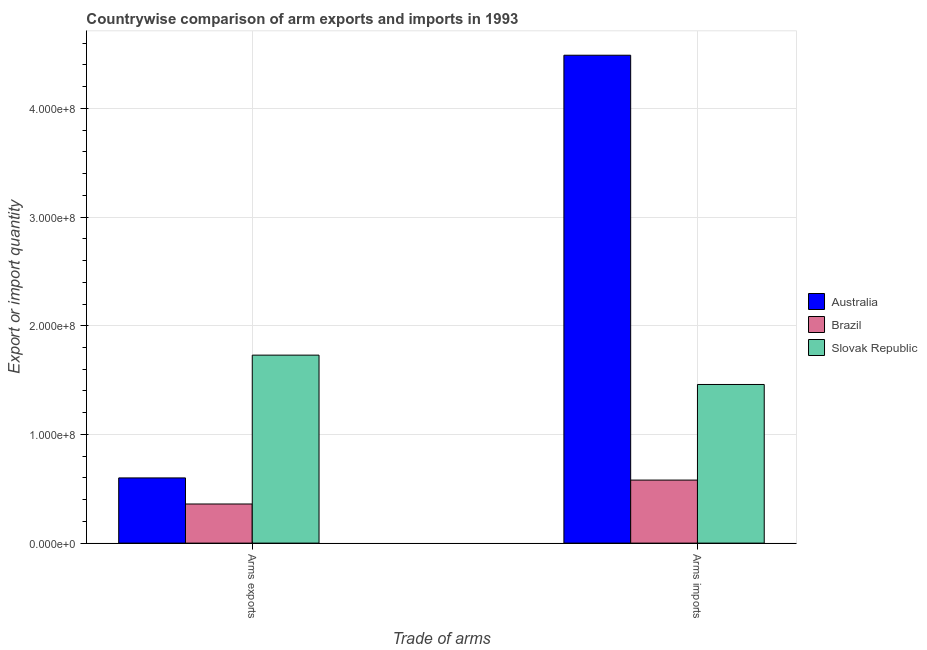How many groups of bars are there?
Keep it short and to the point. 2. Are the number of bars on each tick of the X-axis equal?
Your response must be concise. Yes. How many bars are there on the 1st tick from the left?
Offer a terse response. 3. What is the label of the 2nd group of bars from the left?
Your answer should be very brief. Arms imports. What is the arms imports in Slovak Republic?
Your answer should be compact. 1.46e+08. Across all countries, what is the maximum arms imports?
Provide a succinct answer. 4.49e+08. Across all countries, what is the minimum arms imports?
Your answer should be compact. 5.80e+07. In which country was the arms exports minimum?
Ensure brevity in your answer.  Brazil. What is the total arms exports in the graph?
Your answer should be very brief. 2.69e+08. What is the difference between the arms exports in Australia and that in Brazil?
Your answer should be compact. 2.40e+07. What is the difference between the arms exports in Slovak Republic and the arms imports in Brazil?
Your answer should be compact. 1.15e+08. What is the average arms imports per country?
Provide a short and direct response. 2.18e+08. What is the difference between the arms exports and arms imports in Brazil?
Your answer should be compact. -2.20e+07. In how many countries, is the arms exports greater than 120000000 ?
Offer a very short reply. 1. What is the ratio of the arms exports in Slovak Republic to that in Brazil?
Your answer should be very brief. 4.81. What does the 3rd bar from the left in Arms exports represents?
Ensure brevity in your answer.  Slovak Republic. What does the 1st bar from the right in Arms exports represents?
Give a very brief answer. Slovak Republic. Are all the bars in the graph horizontal?
Provide a succinct answer. No. How many countries are there in the graph?
Give a very brief answer. 3. Are the values on the major ticks of Y-axis written in scientific E-notation?
Give a very brief answer. Yes. Does the graph contain grids?
Your answer should be compact. Yes. Where does the legend appear in the graph?
Make the answer very short. Center right. How many legend labels are there?
Your answer should be very brief. 3. What is the title of the graph?
Offer a terse response. Countrywise comparison of arm exports and imports in 1993. What is the label or title of the X-axis?
Keep it short and to the point. Trade of arms. What is the label or title of the Y-axis?
Your response must be concise. Export or import quantity. What is the Export or import quantity in Australia in Arms exports?
Make the answer very short. 6.00e+07. What is the Export or import quantity in Brazil in Arms exports?
Keep it short and to the point. 3.60e+07. What is the Export or import quantity of Slovak Republic in Arms exports?
Your response must be concise. 1.73e+08. What is the Export or import quantity of Australia in Arms imports?
Your response must be concise. 4.49e+08. What is the Export or import quantity in Brazil in Arms imports?
Your answer should be compact. 5.80e+07. What is the Export or import quantity of Slovak Republic in Arms imports?
Offer a terse response. 1.46e+08. Across all Trade of arms, what is the maximum Export or import quantity in Australia?
Offer a very short reply. 4.49e+08. Across all Trade of arms, what is the maximum Export or import quantity of Brazil?
Keep it short and to the point. 5.80e+07. Across all Trade of arms, what is the maximum Export or import quantity in Slovak Republic?
Offer a very short reply. 1.73e+08. Across all Trade of arms, what is the minimum Export or import quantity in Australia?
Offer a terse response. 6.00e+07. Across all Trade of arms, what is the minimum Export or import quantity in Brazil?
Keep it short and to the point. 3.60e+07. Across all Trade of arms, what is the minimum Export or import quantity of Slovak Republic?
Offer a very short reply. 1.46e+08. What is the total Export or import quantity in Australia in the graph?
Provide a succinct answer. 5.09e+08. What is the total Export or import quantity in Brazil in the graph?
Make the answer very short. 9.40e+07. What is the total Export or import quantity in Slovak Republic in the graph?
Your answer should be compact. 3.19e+08. What is the difference between the Export or import quantity in Australia in Arms exports and that in Arms imports?
Provide a succinct answer. -3.89e+08. What is the difference between the Export or import quantity in Brazil in Arms exports and that in Arms imports?
Give a very brief answer. -2.20e+07. What is the difference between the Export or import quantity in Slovak Republic in Arms exports and that in Arms imports?
Give a very brief answer. 2.70e+07. What is the difference between the Export or import quantity of Australia in Arms exports and the Export or import quantity of Brazil in Arms imports?
Give a very brief answer. 2.00e+06. What is the difference between the Export or import quantity in Australia in Arms exports and the Export or import quantity in Slovak Republic in Arms imports?
Provide a succinct answer. -8.60e+07. What is the difference between the Export or import quantity in Brazil in Arms exports and the Export or import quantity in Slovak Republic in Arms imports?
Your response must be concise. -1.10e+08. What is the average Export or import quantity in Australia per Trade of arms?
Offer a terse response. 2.54e+08. What is the average Export or import quantity of Brazil per Trade of arms?
Provide a succinct answer. 4.70e+07. What is the average Export or import quantity in Slovak Republic per Trade of arms?
Give a very brief answer. 1.60e+08. What is the difference between the Export or import quantity of Australia and Export or import quantity of Brazil in Arms exports?
Offer a very short reply. 2.40e+07. What is the difference between the Export or import quantity in Australia and Export or import quantity in Slovak Republic in Arms exports?
Ensure brevity in your answer.  -1.13e+08. What is the difference between the Export or import quantity of Brazil and Export or import quantity of Slovak Republic in Arms exports?
Your response must be concise. -1.37e+08. What is the difference between the Export or import quantity in Australia and Export or import quantity in Brazil in Arms imports?
Keep it short and to the point. 3.91e+08. What is the difference between the Export or import quantity in Australia and Export or import quantity in Slovak Republic in Arms imports?
Ensure brevity in your answer.  3.03e+08. What is the difference between the Export or import quantity in Brazil and Export or import quantity in Slovak Republic in Arms imports?
Keep it short and to the point. -8.80e+07. What is the ratio of the Export or import quantity in Australia in Arms exports to that in Arms imports?
Offer a very short reply. 0.13. What is the ratio of the Export or import quantity of Brazil in Arms exports to that in Arms imports?
Give a very brief answer. 0.62. What is the ratio of the Export or import quantity in Slovak Republic in Arms exports to that in Arms imports?
Offer a terse response. 1.18. What is the difference between the highest and the second highest Export or import quantity in Australia?
Your answer should be very brief. 3.89e+08. What is the difference between the highest and the second highest Export or import quantity of Brazil?
Keep it short and to the point. 2.20e+07. What is the difference between the highest and the second highest Export or import quantity of Slovak Republic?
Offer a terse response. 2.70e+07. What is the difference between the highest and the lowest Export or import quantity of Australia?
Your answer should be very brief. 3.89e+08. What is the difference between the highest and the lowest Export or import quantity in Brazil?
Give a very brief answer. 2.20e+07. What is the difference between the highest and the lowest Export or import quantity of Slovak Republic?
Your answer should be very brief. 2.70e+07. 